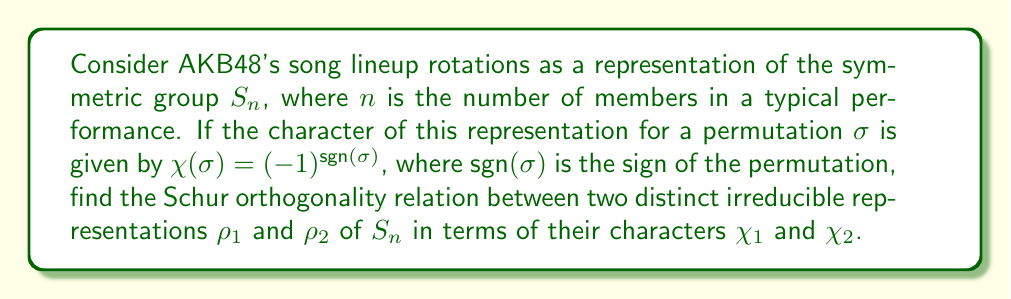Help me with this question. Let's approach this step-by-step:

1) The Schur orthogonality relations state that for two irreducible representations $\rho_1$ and $\rho_2$ of a finite group $G$:

   $$\frac{1}{|G|} \sum_{g \in G} \chi_1(g) \overline{\chi_2(g)} = \delta_{\rho_1,\rho_2}$$

   where $\delta_{\rho_1,\rho_2}$ is the Kronecker delta.

2) In our case, $G = S_n$, the symmetric group on $n$ elements.

3) We're given that $\chi(\sigma) = (-1)^{\text{sgn}(\sigma)}$. This is actually the sign representation of $S_n$, which is a 1-dimensional representation.

4) For distinct irreducible representations $\rho_1$ and $\rho_2$, we know that $\rho_1 \neq \rho_2$, so $\delta_{\rho_1,\rho_2} = 0$.

5) Therefore, the Schur orthogonality relation becomes:

   $$\frac{1}{n!} \sum_{\sigma \in S_n} \chi_1(\sigma) \overline{\chi_2(\sigma)} = 0$$

6) This equation holds for any two distinct irreducible representations of $S_n$, including the one given in the problem statement.
Answer: $$\frac{1}{n!} \sum_{\sigma \in S_n} \chi_1(\sigma) \overline{\chi_2(\sigma)} = 0$$ 